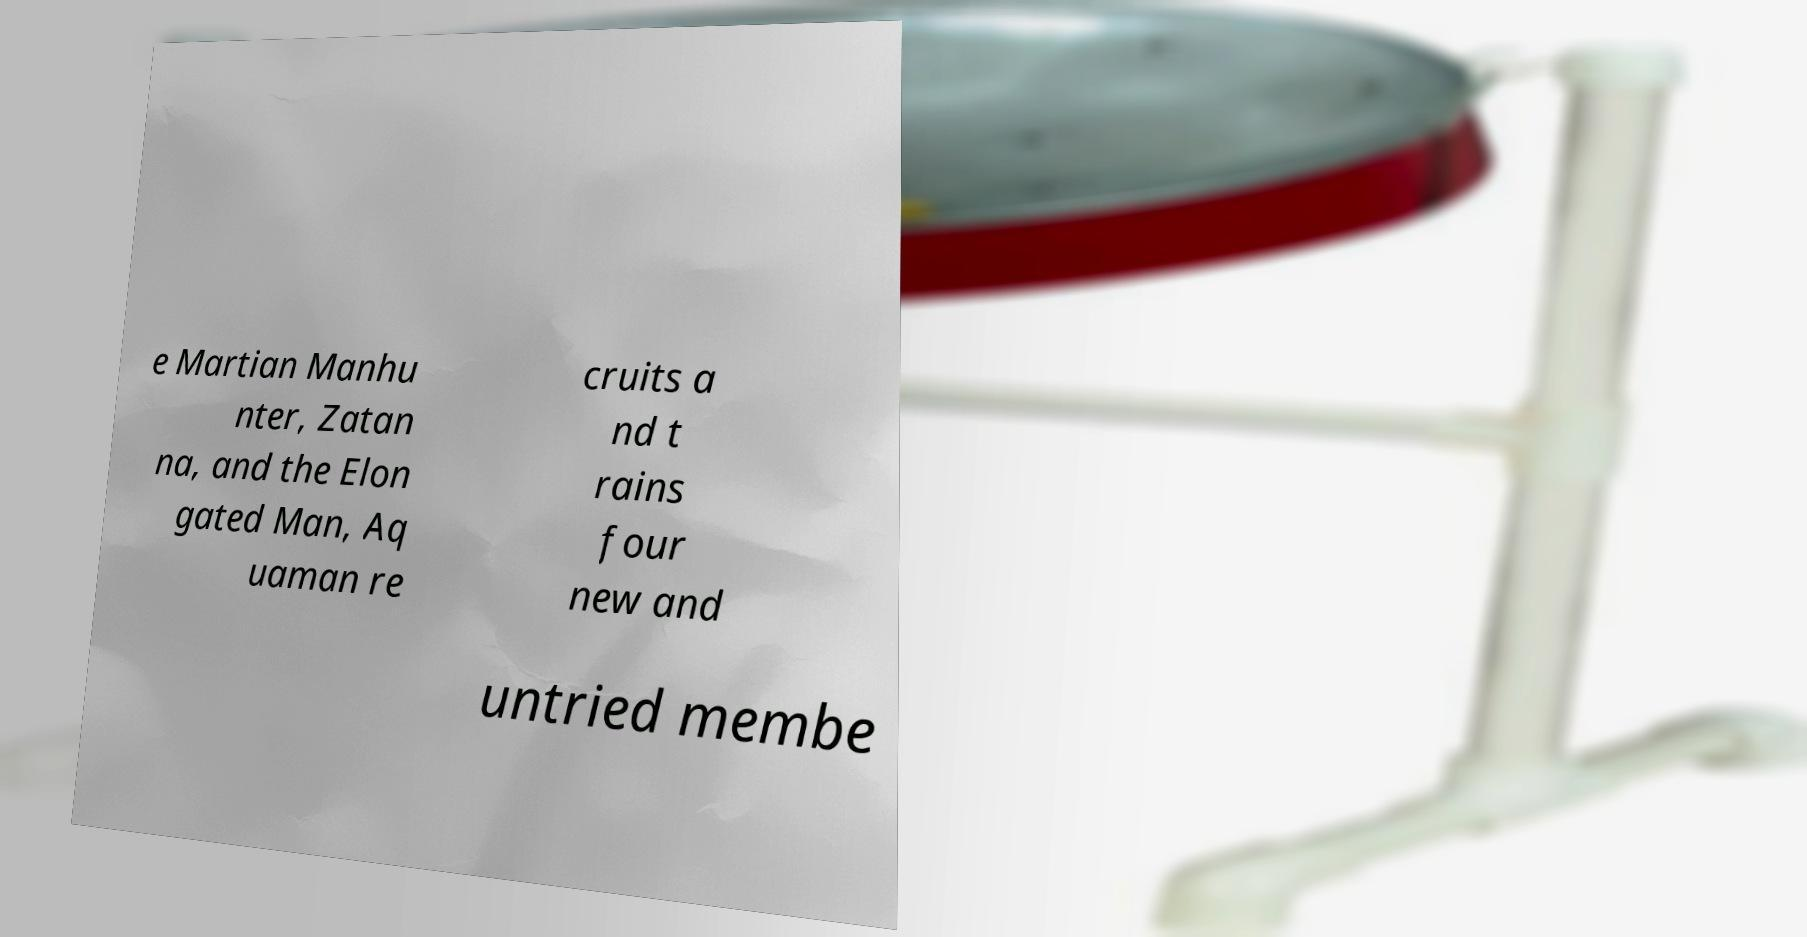Can you read and provide the text displayed in the image?This photo seems to have some interesting text. Can you extract and type it out for me? e Martian Manhu nter, Zatan na, and the Elon gated Man, Aq uaman re cruits a nd t rains four new and untried membe 